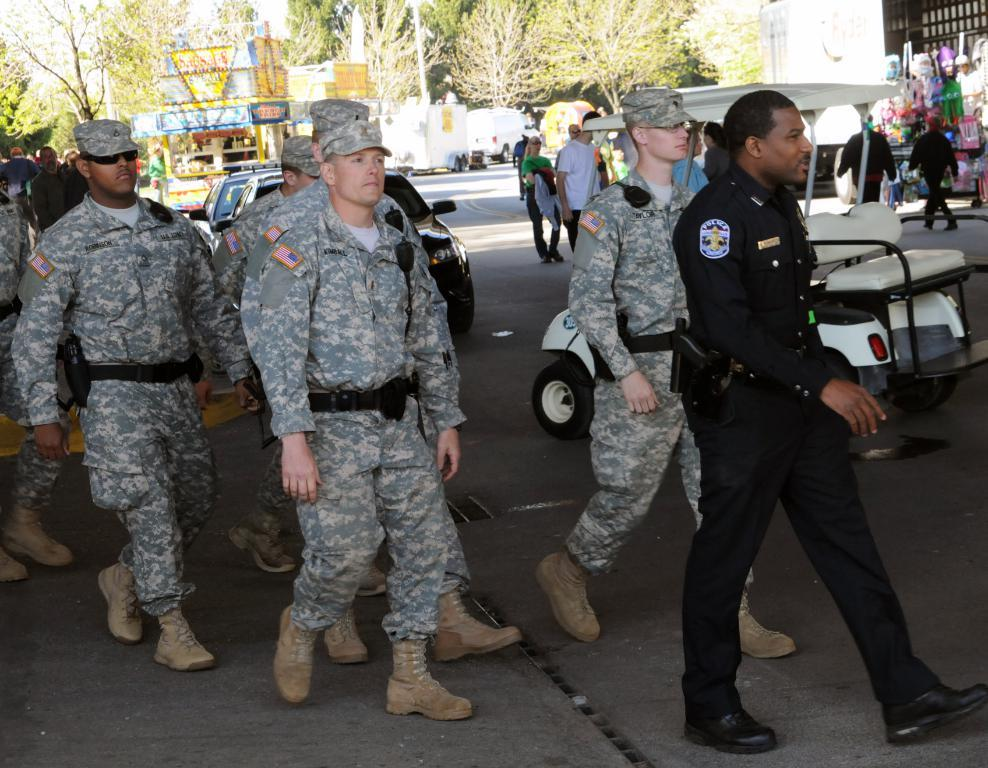How many people are in the image? The number of people in the image cannot be determined from the provided facts. What are some of the people wearing? Some of the people in the image are wearing uniforms. What can be seen on the road in the image? There are vehicles on the road in the image. What is visible in the background of the image? In the background of the image, there are buildings, trees, stalls, and the sky. What grade is the hall in the image? There is no hall present in the image, so it is not possible to determine the grade of any hall. 